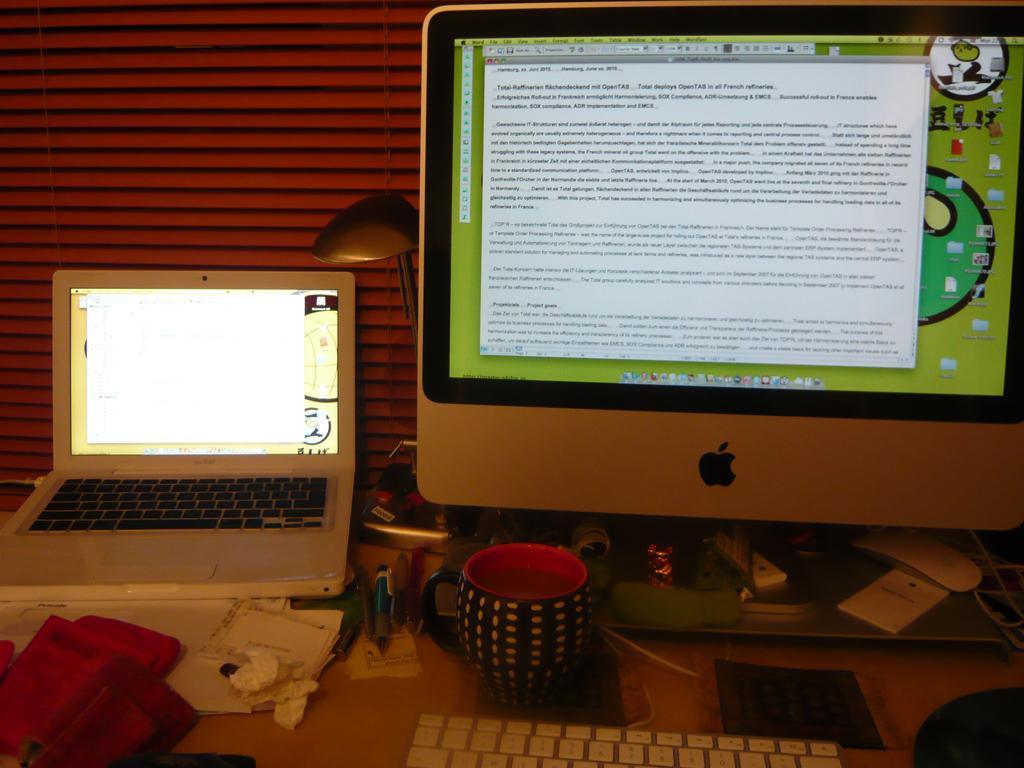Could you give a brief overview of what you see in this image? In this picture we can see on table we have laptop, cpu, monitor, keyboard, cloth, tissue paper, pens and in background we can see wall. 